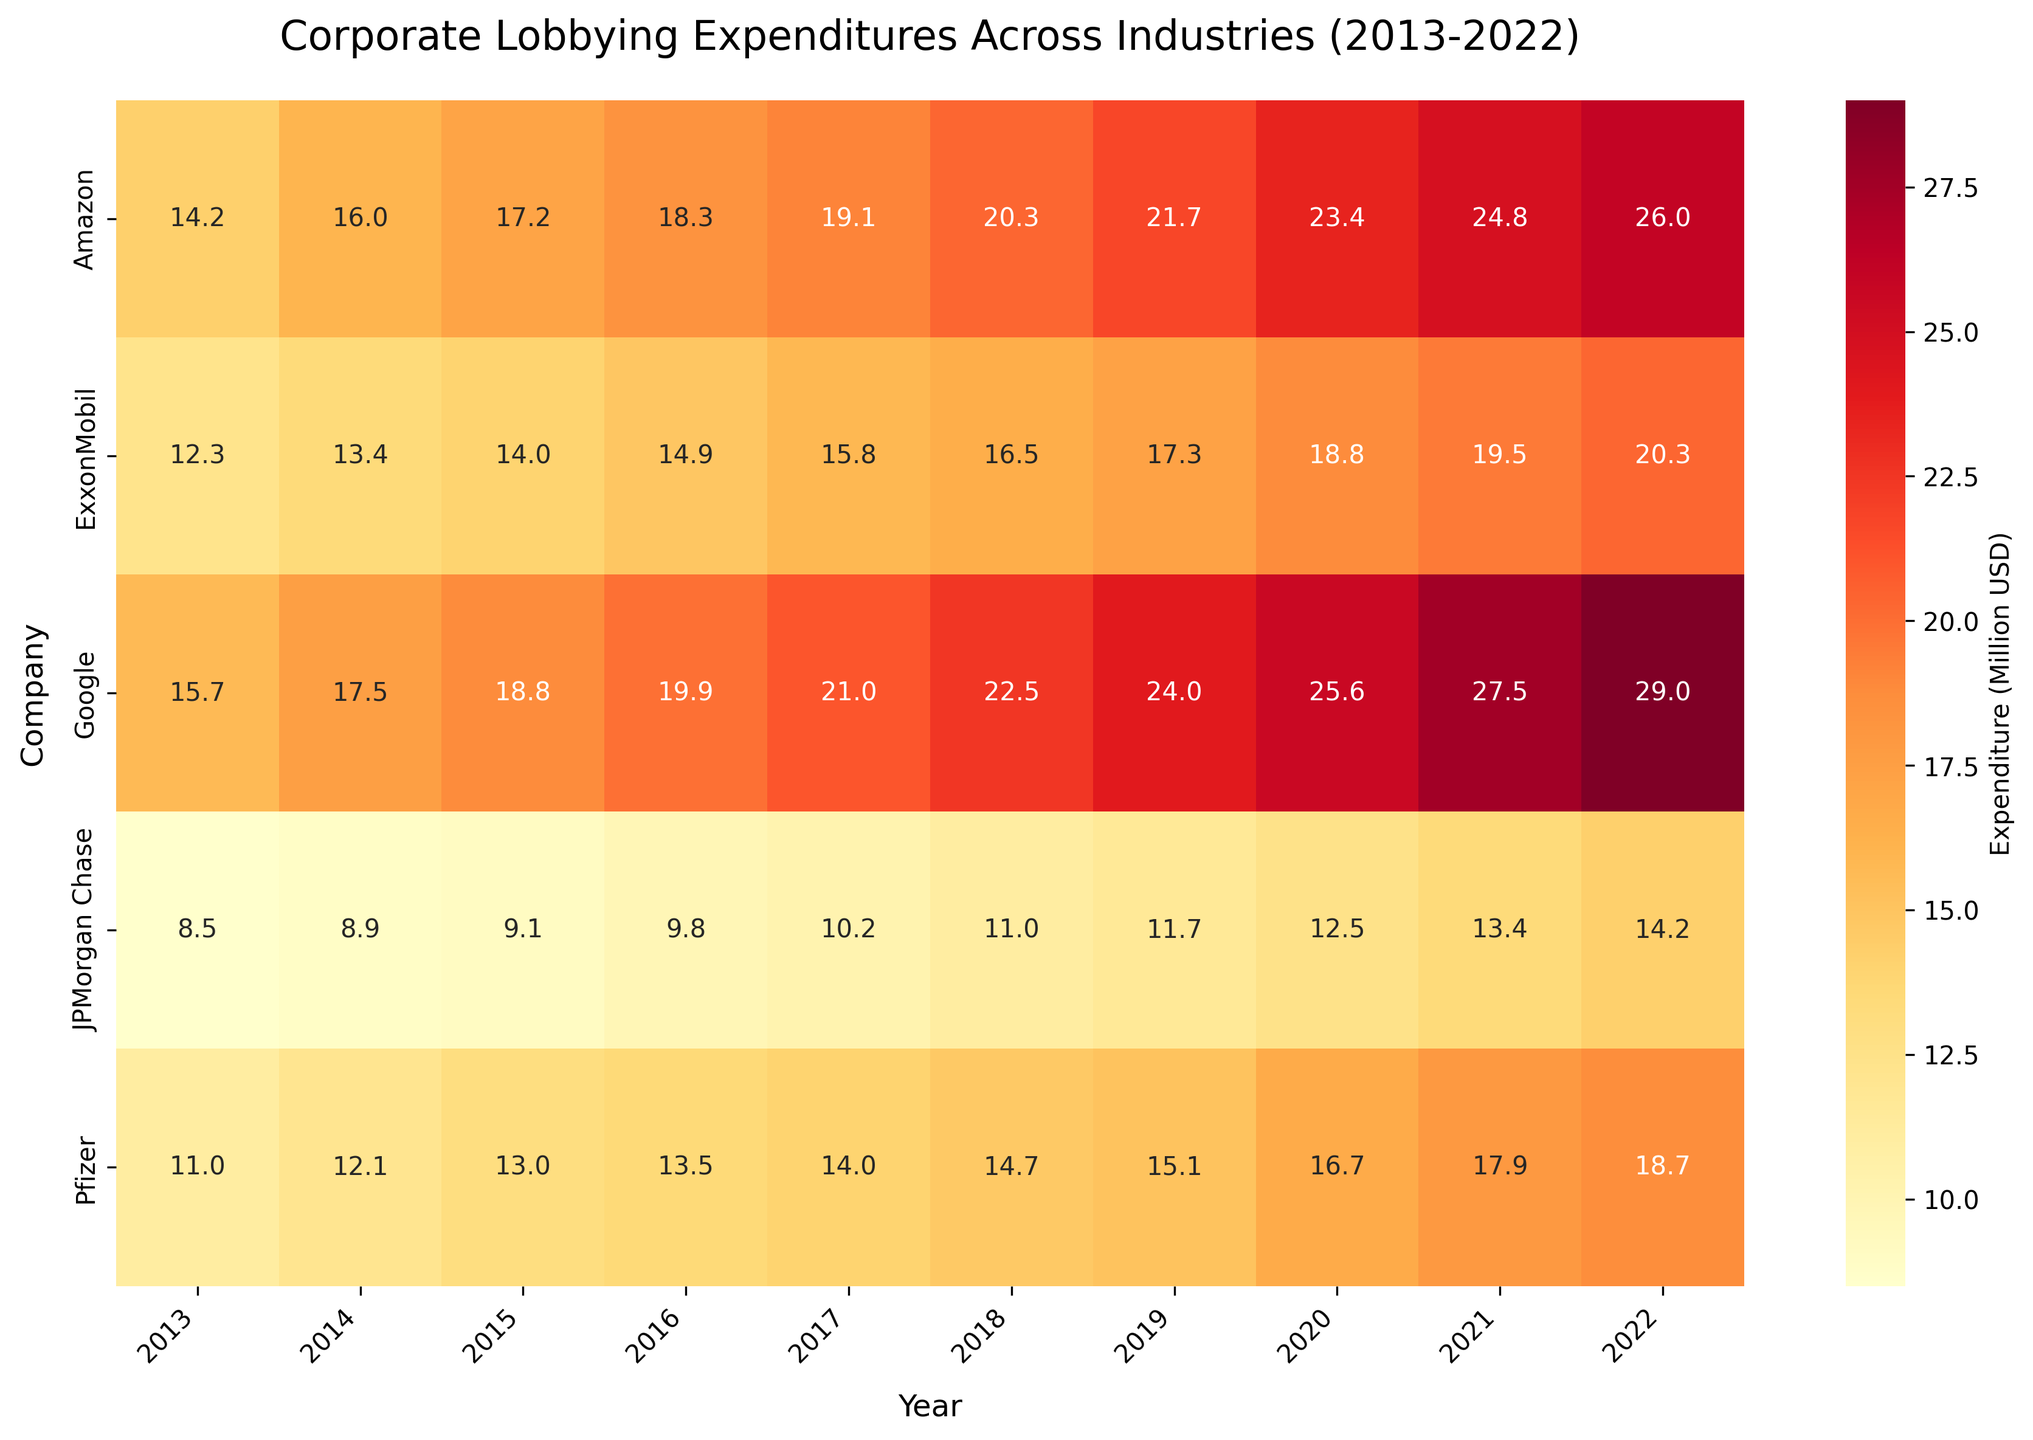Which industry spent the most on lobbying in general between 2013 and 2022? By examining the color intensity of the heatmap across the rows, it can be seen that the Technology industry (companies Amazon and Google) has the highest values across the years.
Answer: Technology What's the total lobbying expenditure for Pfizer from 2013 to 2022? Sum all of Pfizer's expenditures from 2013 to 2022. \(11.0 + 12.1 + 13.0 + 13.5 + 14.0 + 14.7 + 15.1 + 16.7 + 17.9 + 18.7 = 147.7 \) million USD
Answer: 147.7 Which company had the highest expenditure in 2022, and what was the amount? By looking at the 2022 column, the company Google, with 29.0 million USD, has the highest expenditure.
Answer: Google, 29.0 million USD How did Amazon's lobbying expenditure change from 2013 to 2022? Evaluate the expenditure for Amazon in 2013 and compare it to 2022: \(26.0 - 14.2 = 11.8\) million USD increment.
Answer: Increased by 11.8 million USD Which company showed the most noticeable increase in lobbying expenditure over the decade? By comparing the trend across the decade for all companies, Google shows the most noticeable increase, from 15.7 million USD in 2013 to 29.0 million USD in 2022.
Answer: Google Between 2018 and 2020, did JPMorgan Chase's lobbying expenditure increase or decrease, and by how much? Check JPMorgan Chase's values for 2018 and 2020 and calculate the difference: \(12.5 - 11.0 = 1.5\) million USD increment.
Answer: Increased by 1.5 million USD What was the average lobbying expenditure of ExxonMobil over the decade from 2013 to 2022? Sum all yearly expenditures for ExxonMobil and divide by the number of years: \((12.3 + 13.4 + 14.0 + 14.9 + 15.8 + 16.5 + 17.3 + 18.8 + 19.5 + 20.3) / 10 = 16.58\).
Answer: 16.6 million USD Was there any year in which Pfizer’s lobbying expenditure did not increase compared to the previous year? Compare Pfizer's expenditures year by year: 2016 and 2017 both show the same expenditure of 14.0 million USD.
Answer: Yes, in 2017 Compare the trend of lobbying expenditure over the decade for Amazon and JPMorgan Chase. Amazon's expenditure has a consistent upward trend every year, while JPMorgan Chase's expenditure sees smaller, inconsistent increments.
Answer: Amazon consistently up, JPMorgan Chase variable Which company had the smallest lobbying expenditure increase from 2013 to 2022? Calculate the change for each company. JPMorgan Chase had the smallest increase from 8.5 (2013) to 14.2 (2022), resulting in a 5.7 million USD increment.
Answer: JPMorgan Chase 